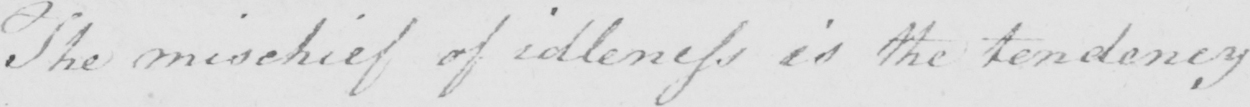Please provide the text content of this handwritten line. The mischief of idleness is the tendency 